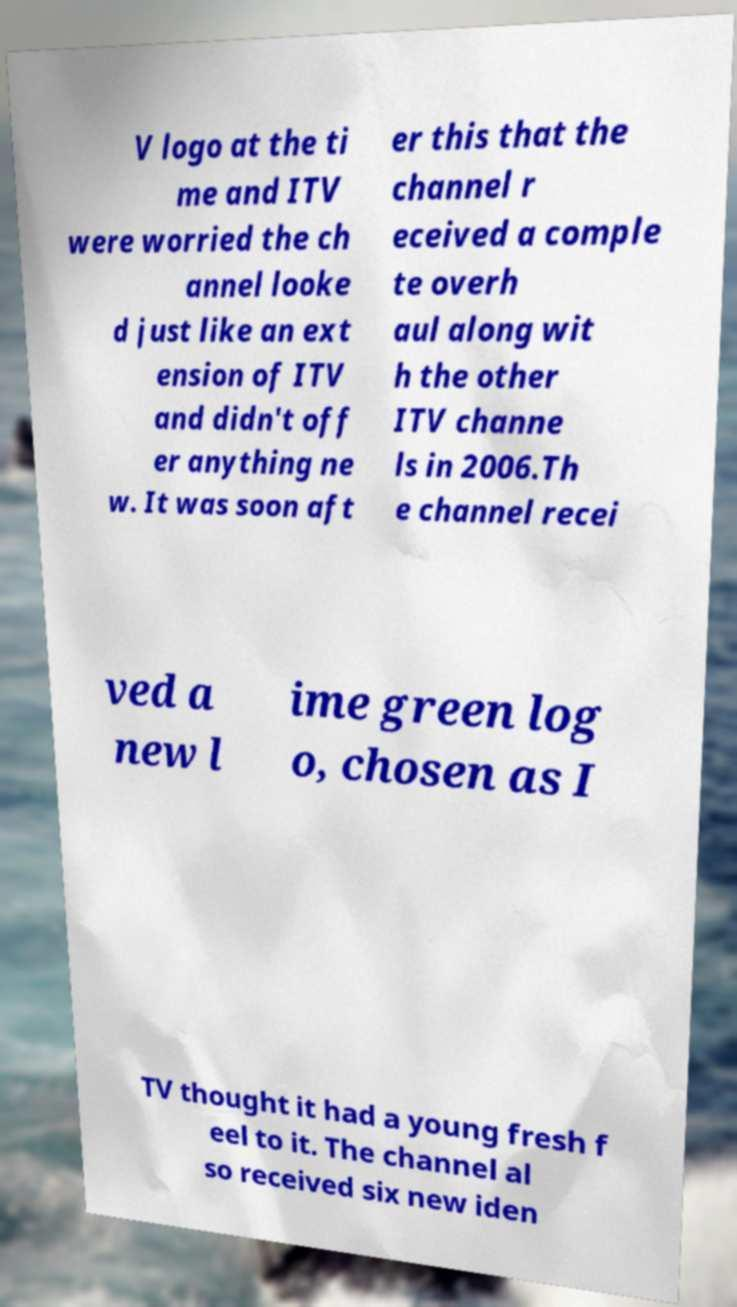For documentation purposes, I need the text within this image transcribed. Could you provide that? V logo at the ti me and ITV were worried the ch annel looke d just like an ext ension of ITV and didn't off er anything ne w. It was soon aft er this that the channel r eceived a comple te overh aul along wit h the other ITV channe ls in 2006.Th e channel recei ved a new l ime green log o, chosen as I TV thought it had a young fresh f eel to it. The channel al so received six new iden 